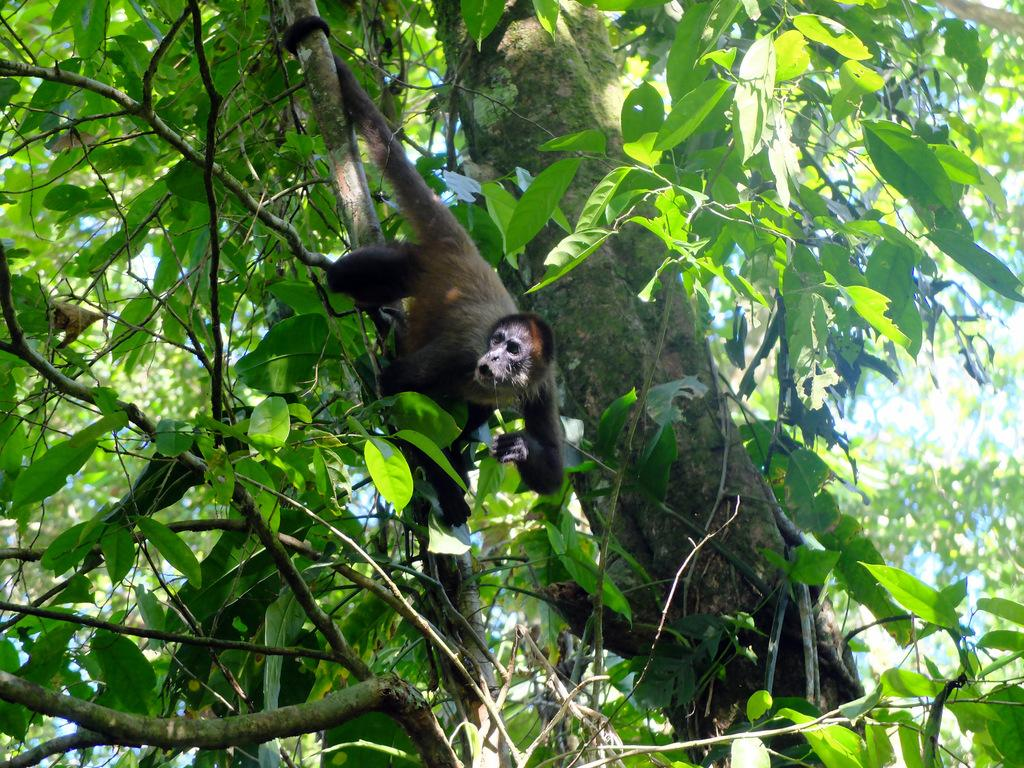What is the main subject in the center of the image? There is a monkey in the center of the image. What type of natural environment is depicted in the image? There are trees in the image, suggesting a forest or jungle setting. Where is the queen sitting in the image? There is no queen present in the image; it features a monkey and trees. What is the monkey saying as it waves good-bye in the image? The image does not depict the monkey speaking or waving good-bye. 